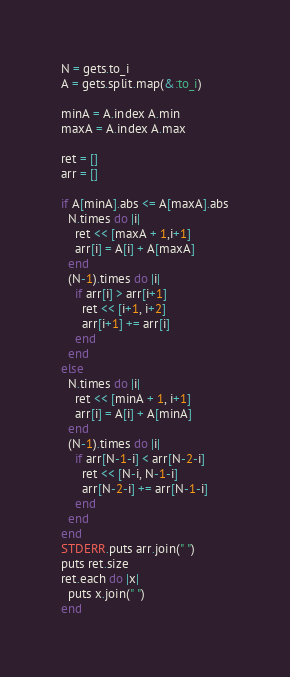<code> <loc_0><loc_0><loc_500><loc_500><_Ruby_>N = gets.to_i
A = gets.split.map(&:to_i)

minA = A.index A.min
maxA = A.index A.max

ret = []
arr = []

if A[minA].abs <= A[maxA].abs
  N.times do |i|
    ret << [maxA + 1,i+1]
    arr[i] = A[i] + A[maxA]
  end
  (N-1).times do |i|
    if arr[i] > arr[i+1]
      ret << [i+1, i+2]
      arr[i+1] += arr[i]
    end
  end
else
  N.times do |i|
    ret << [minA + 1, i+1]
    arr[i] = A[i] + A[minA]
  end
  (N-1).times do |i|
    if arr[N-1-i] < arr[N-2-i]
      ret << [N-i, N-1-i]
      arr[N-2-i] += arr[N-1-i]
    end
  end
end
STDERR.puts arr.join(" ")
puts ret.size
ret.each do |x|
  puts x.join(" ")
end
</code> 